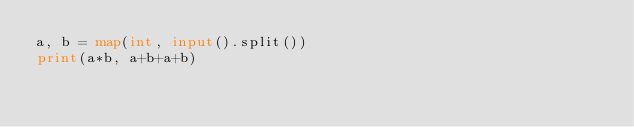Convert code to text. <code><loc_0><loc_0><loc_500><loc_500><_Python_>a, b = map(int, input().split())
print(a*b, a+b+a+b)

</code> 